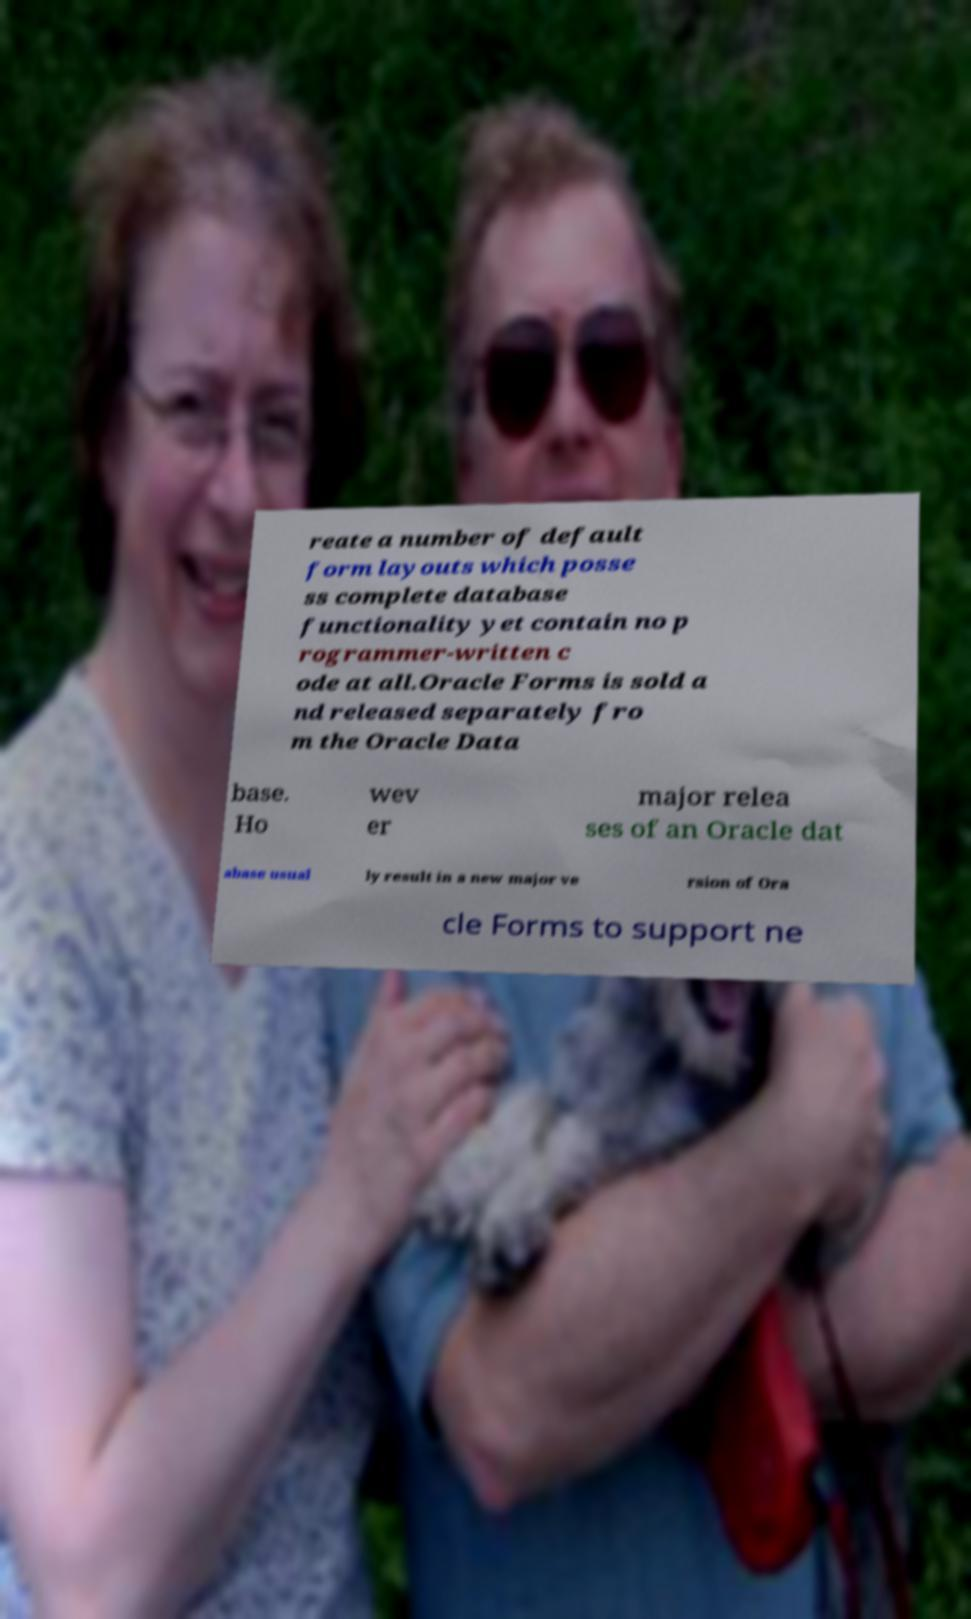Please identify and transcribe the text found in this image. reate a number of default form layouts which posse ss complete database functionality yet contain no p rogrammer-written c ode at all.Oracle Forms is sold a nd released separately fro m the Oracle Data base. Ho wev er major relea ses of an Oracle dat abase usual ly result in a new major ve rsion of Ora cle Forms to support ne 